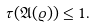<formula> <loc_0><loc_0><loc_500><loc_500>\tau ( { \mathfrak { A } } ( \varrho ) ) \leq 1 .</formula> 